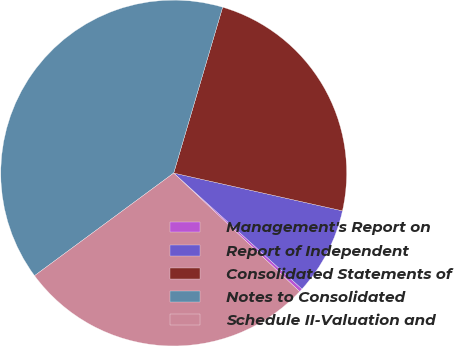Convert chart to OTSL. <chart><loc_0><loc_0><loc_500><loc_500><pie_chart><fcel>Management's Report on<fcel>Report of Independent<fcel>Consolidated Statements of<fcel>Notes to Consolidated<fcel>Schedule II-Valuation and<nl><fcel>0.32%<fcel>8.19%<fcel>23.94%<fcel>39.68%<fcel>27.87%<nl></chart> 